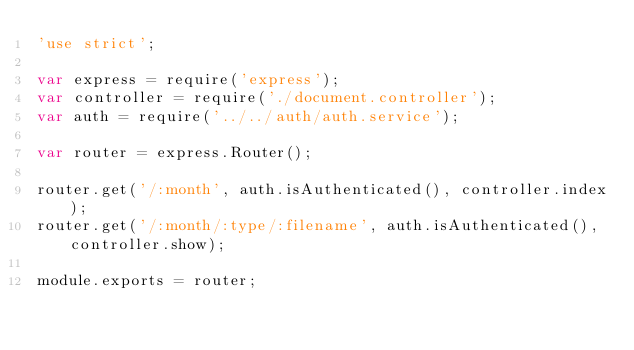<code> <loc_0><loc_0><loc_500><loc_500><_JavaScript_>'use strict';

var express = require('express');
var controller = require('./document.controller');
var auth = require('../../auth/auth.service');

var router = express.Router();

router.get('/:month', auth.isAuthenticated(), controller.index);
router.get('/:month/:type/:filename', auth.isAuthenticated(), controller.show);

module.exports = router;</code> 